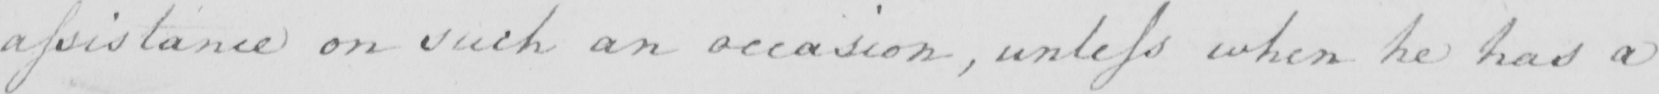What does this handwritten line say? assistance on such an occasion , unless when he had a 